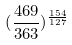Convert formula to latex. <formula><loc_0><loc_0><loc_500><loc_500>( \frac { 4 6 9 } { 3 6 3 } ) ^ { \frac { 1 5 4 } { 1 2 7 } }</formula> 